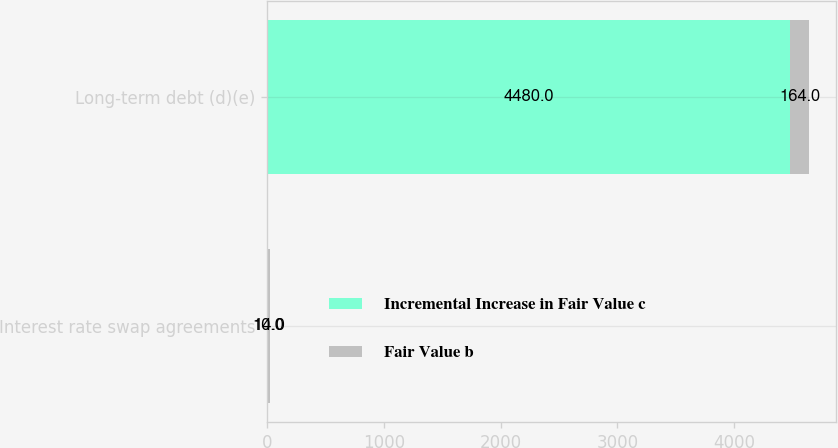Convert chart. <chart><loc_0><loc_0><loc_500><loc_500><stacked_bar_chart><ecel><fcel>Interest rate swap agreements<fcel>Long-term debt (d)(e)<nl><fcel>Incremental Increase in Fair Value c<fcel>10<fcel>4480<nl><fcel>Fair Value b<fcel>14<fcel>164<nl></chart> 